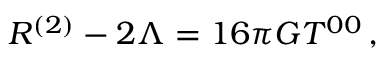Convert formula to latex. <formula><loc_0><loc_0><loc_500><loc_500>R ^ { ( 2 ) } - 2 \Lambda = 1 6 \pi G T ^ { 0 0 } \, ,</formula> 